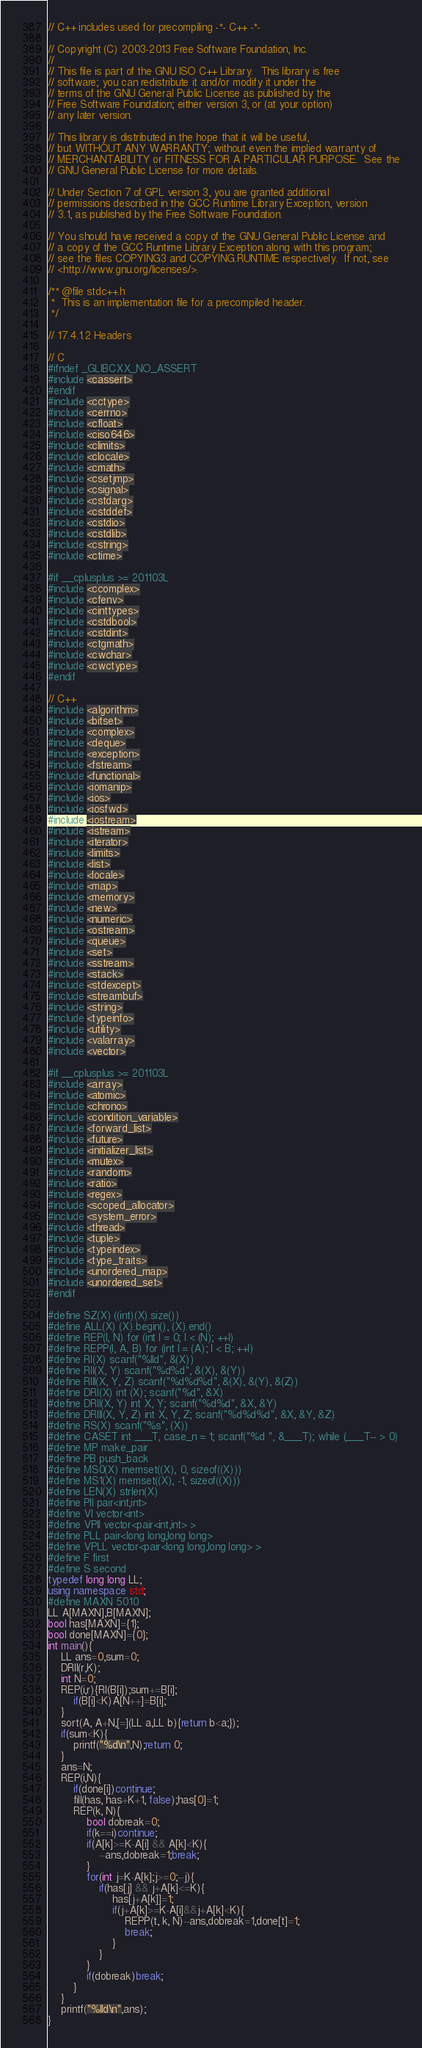Convert code to text. <code><loc_0><loc_0><loc_500><loc_500><_C++_>// C++ includes used for precompiling -*- C++ -*-

// Copyright (C) 2003-2013 Free Software Foundation, Inc.
//
// This file is part of the GNU ISO C++ Library.  This library is free
// software; you can redistribute it and/or modify it under the
// terms of the GNU General Public License as published by the
// Free Software Foundation; either version 3, or (at your option)
// any later version.

// This library is distributed in the hope that it will be useful,
// but WITHOUT ANY WARRANTY; without even the implied warranty of
// MERCHANTABILITY or FITNESS FOR A PARTICULAR PURPOSE.  See the
// GNU General Public License for more details.

// Under Section 7 of GPL version 3, you are granted additional
// permissions described in the GCC Runtime Library Exception, version
// 3.1, as published by the Free Software Foundation.

// You should have received a copy of the GNU General Public License and
// a copy of the GCC Runtime Library Exception along with this program;
// see the files COPYING3 and COPYING.RUNTIME respectively.  If not, see
// <http://www.gnu.org/licenses/>.

/** @file stdc++.h
 *  This is an implementation file for a precompiled header.
 */

// 17.4.1.2 Headers

// C
#ifndef _GLIBCXX_NO_ASSERT
#include <cassert>
#endif
#include <cctype>
#include <cerrno>
#include <cfloat>
#include <ciso646>
#include <climits>
#include <clocale>
#include <cmath>
#include <csetjmp>
#include <csignal>
#include <cstdarg>
#include <cstddef>
#include <cstdio>
#include <cstdlib>
#include <cstring>
#include <ctime>

#if __cplusplus >= 201103L
#include <ccomplex>
#include <cfenv>
#include <cinttypes>
#include <cstdbool>
#include <cstdint>
#include <ctgmath>
#include <cwchar>
#include <cwctype>
#endif

// C++
#include <algorithm>
#include <bitset>
#include <complex>
#include <deque>
#include <exception>
#include <fstream>
#include <functional>
#include <iomanip>
#include <ios>
#include <iosfwd>
#include <iostream>
#include <istream>
#include <iterator>
#include <limits>
#include <list>
#include <locale>
#include <map>
#include <memory>
#include <new>
#include <numeric>
#include <ostream>
#include <queue>
#include <set>
#include <sstream>
#include <stack>
#include <stdexcept>
#include <streambuf>
#include <string>
#include <typeinfo>
#include <utility>
#include <valarray>
#include <vector>

#if __cplusplus >= 201103L
#include <array>
#include <atomic>
#include <chrono>
#include <condition_variable>
#include <forward_list>
#include <future>
#include <initializer_list>
#include <mutex>
#include <random>
#include <ratio>
#include <regex>
#include <scoped_allocator>
#include <system_error>
#include <thread>
#include <tuple>
#include <typeindex>
#include <type_traits>
#include <unordered_map>
#include <unordered_set>
#endif

#define SZ(X) ((int)(X).size())
#define ALL(X) (X).begin(), (X).end()
#define REP(I, N) for (int I = 0; I < (N); ++I)
#define REPP(I, A, B) for (int I = (A); I < B; ++I)
#define RI(X) scanf("%lld", &(X))
#define RII(X, Y) scanf("%d%d", &(X), &(Y))
#define RIII(X, Y, Z) scanf("%d%d%d", &(X), &(Y), &(Z))
#define DRI(X) int (X); scanf("%d", &X)
#define DRII(X, Y) int X, Y; scanf("%d%d", &X, &Y)
#define DRIII(X, Y, Z) int X, Y, Z; scanf("%d%d%d", &X, &Y, &Z)
#define RS(X) scanf("%s", (X))
#define CASET int ___T, case_n = 1; scanf("%d ", &___T); while (___T-- > 0)
#define MP make_pair
#define PB push_back
#define MS0(X) memset((X), 0, sizeof((X)))
#define MS1(X) memset((X), -1, sizeof((X)))
#define LEN(X) strlen(X)
#define PII pair<int,int>
#define VI vector<int>
#define VPII vector<pair<int,int> >
#define PLL pair<long long,long long>
#define VPLL vector<pair<long long,long long> >
#define F first
#define S second
typedef long long LL;
using namespace std;
#define MAXN 5010
LL A[MAXN],B[MAXN];
bool has[MAXN]={1};
bool done[MAXN]={0};
int main(){
    LL ans=0,sum=0;
    DRII(r,K);
    int N=0;
    REP(i,r){RI(B[i]);sum+=B[i];
        if(B[i]<K)A[N++]=B[i];
    }
    sort(A, A+N,[=](LL a,LL b){return b<a;});
    if(sum<K){
        printf("%d\n",N);return 0;
    }
    ans=N;
    REP(i,N){
        if(done[i])continue;
        fill(has, has+K+1, false);has[0]=1;
        REP(k, N){
            bool dobreak=0;
            if(k==i)continue;
            if(A[k]>=K-A[i] && A[k]<K){
                --ans,dobreak=1;break;
            }
            for(int j=K-A[k];j>=0;--j){
                if(has[j] && j+A[k]<=K){
                    has[j+A[k]]=1;
                    if(j+A[k]>=K-A[i]&&j+A[k]<K){
                        REPP(t, k, N)--ans,dobreak=1,done[t]=1;
                        break;
                    }
                }
            }
            if(dobreak)break;
        }
    }
    printf("%lld\n",ans);
}</code> 